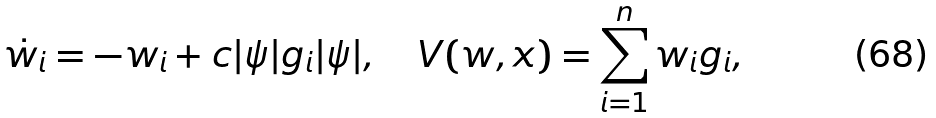<formula> <loc_0><loc_0><loc_500><loc_500>\dot { w } _ { i } = - w _ { i } + c | \psi | g _ { i } | \psi | , \quad V ( w , x ) = \sum _ { i = 1 } ^ { n } w _ { i } g _ { i } ,</formula> 